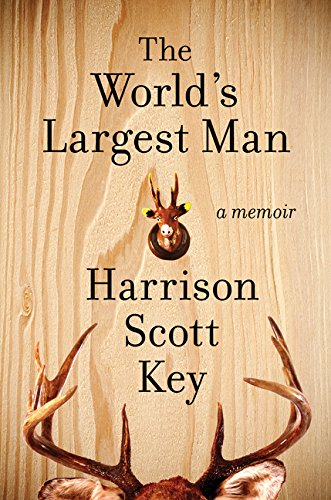What is the significance of the deer ornaments depicted on the cover of this book? The deer ornaments, particularly the antlers, on the cover symbolize traditional aspects of Southern Americana, reflecting elements of the author's upbringing in Mississippi, where hunting and outdoor culture are prevalent. 